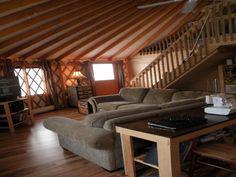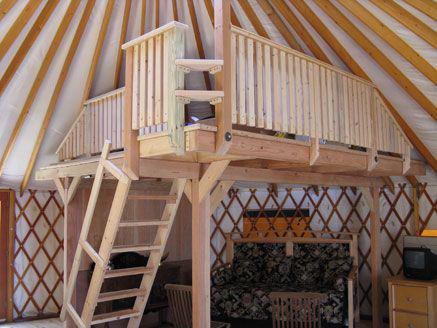The first image is the image on the left, the second image is the image on the right. Examine the images to the left and right. Is the description "A ladder goes up to an upper area of the hut in one of the images." accurate? Answer yes or no. Yes. The first image is the image on the left, the second image is the image on the right. For the images shown, is this caption "A ladder with rungs leads up to a loft area in at least one image." true? Answer yes or no. Yes. The first image is the image on the left, the second image is the image on the right. Given the left and right images, does the statement "One of the images is of a bedroom." hold true? Answer yes or no. No. 